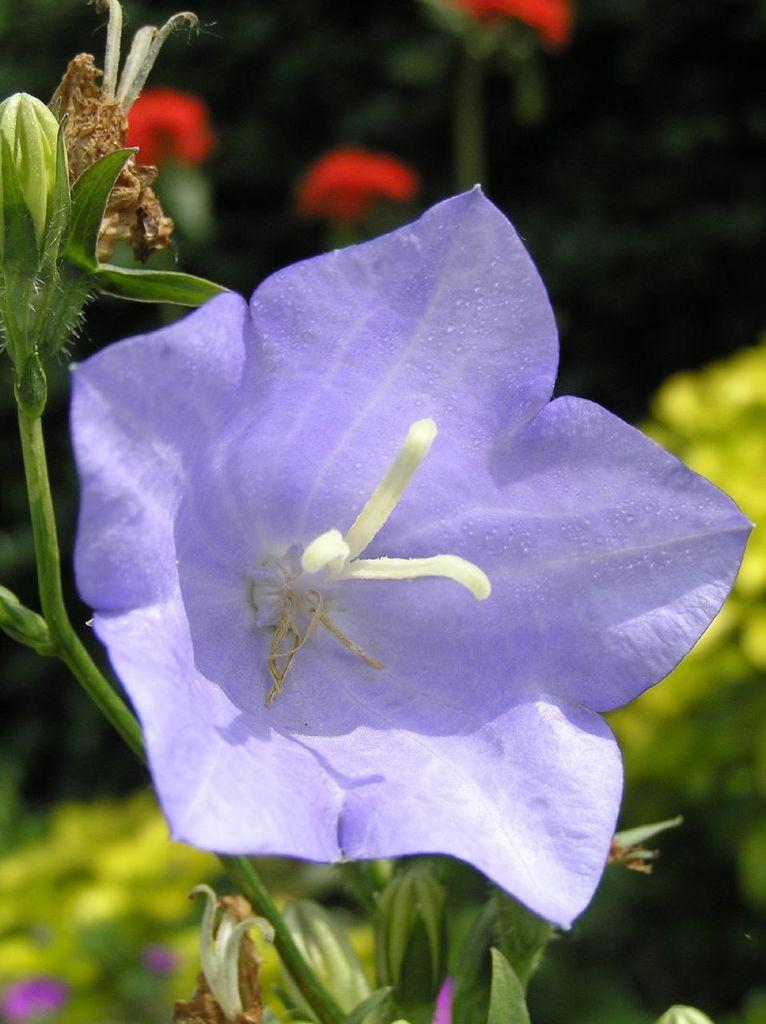What is present in the image? There is a plant in the image. What specific feature can be observed on the plant? The plant has a flower. Can you describe the background of the image be described? The background of the image is blurred. How many bears can be seen interacting with the plant in the image? There are no bears present in the image; it features a plant with a flower and a blurred background. What form does the plant take in the image? The plant takes the form of a plant with a flower, as described in the facts. 